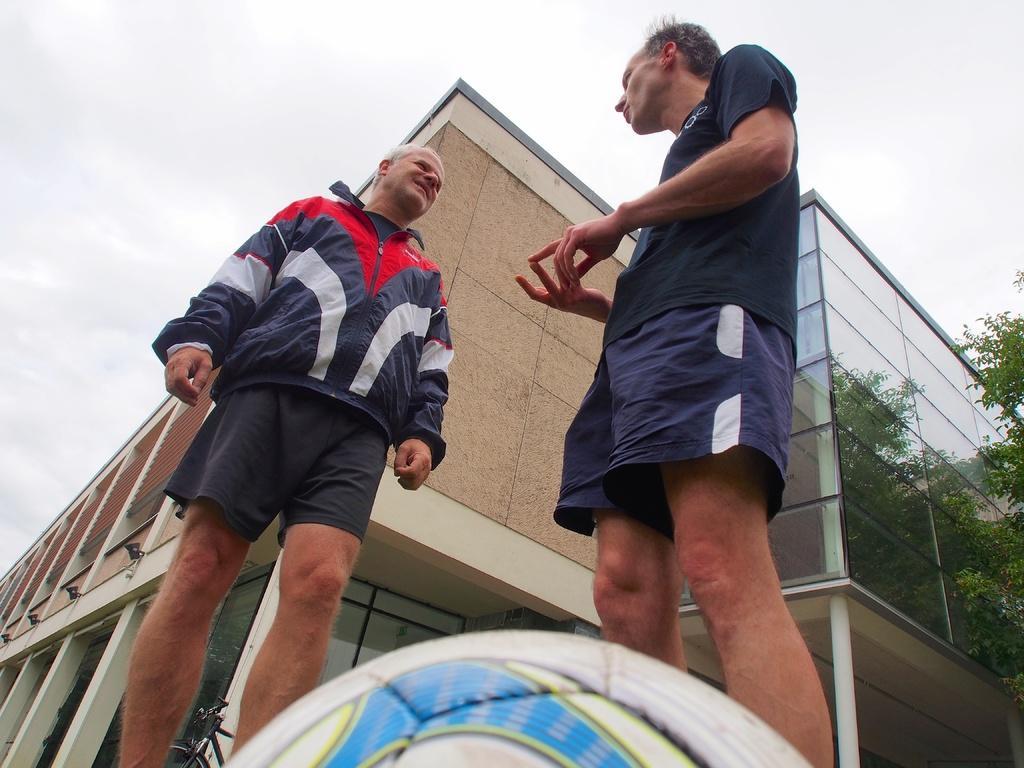Could you give a brief overview of what you see in this image? In this image we can see two persons standing and facing towards the each other, behind them are some buildings with the glass, trees and a bicycle. 